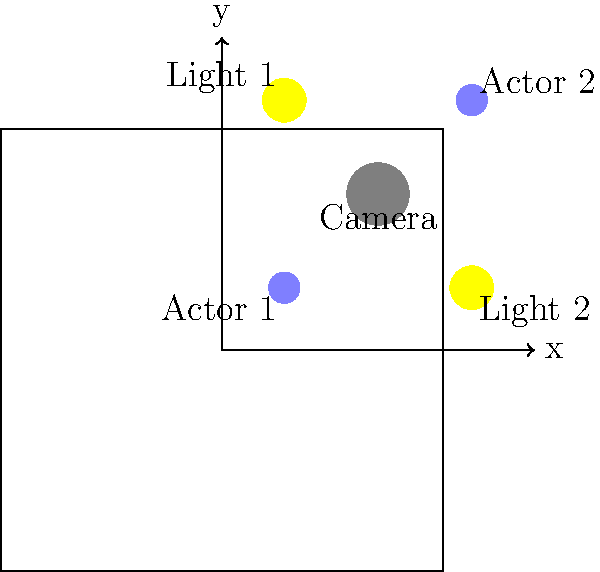In the given film set layout, what is the shortest distance an actor needs to move to be equidistant from both lighting sources? To solve this problem, we need to follow these steps:

1. Identify the coordinates of the two lighting sources:
   Light 1: (0.2, 0.8)
   Light 2: (0.8, 0.2)

2. The point equidistant from both lights will be on the perpendicular bisector of the line segment connecting the two lights.

3. Calculate the midpoint of the line segment between the lights:
   Midpoint = ((0.2 + 0.8)/2, (0.8 + 0.2)/2) = (0.5, 0.5)

4. The perpendicular bisector passes through this midpoint and is perpendicular to the line connecting the lights.

5. The line connecting the lights has a slope of -1, so the perpendicular bisector will have a slope of 1.

6. The equation of the perpendicular bisector is:
   y - 0.5 = 1(x - 0.5) or y = x

7. The shortest distance an actor needs to move is the distance from their current position to the nearest point on this line.

8. For Actor 1 at (0.2, 0.2):
   The nearest point on y = x is (0.2, 0.2), so no movement is needed.

9. For Actor 2 at (0.8, 0.8):
   The nearest point on y = x is (0.8, 0.8), so no movement is needed.

10. Therefore, the shortest distance an actor needs to move is 0.
Answer: 0 